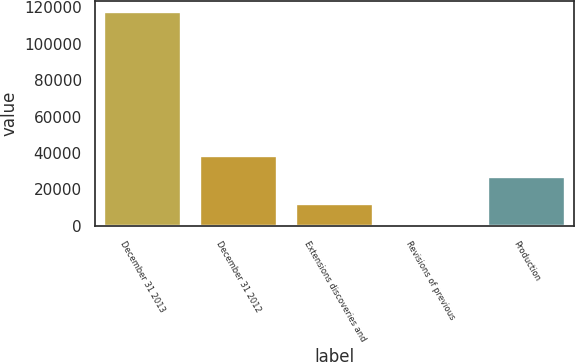Convert chart to OTSL. <chart><loc_0><loc_0><loc_500><loc_500><bar_chart><fcel>December 31 2013<fcel>December 31 2012<fcel>Extensions discoveries and<fcel>Revisions of previous<fcel>Production<nl><fcel>117457<fcel>38565.3<fcel>11767.3<fcel>24<fcel>26822<nl></chart> 